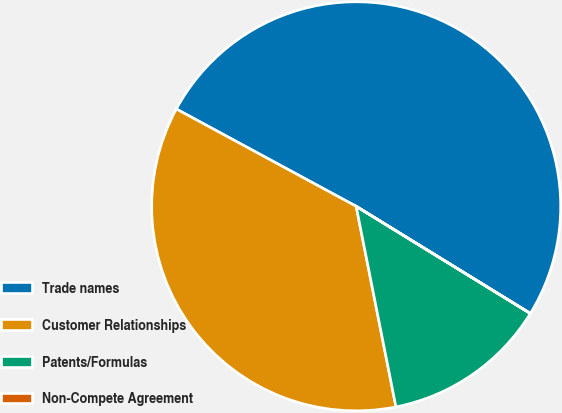Convert chart to OTSL. <chart><loc_0><loc_0><loc_500><loc_500><pie_chart><fcel>Trade names<fcel>Customer Relationships<fcel>Patents/Formulas<fcel>Non-Compete Agreement<nl><fcel>50.88%<fcel>36.01%<fcel>13.1%<fcel>0.01%<nl></chart> 